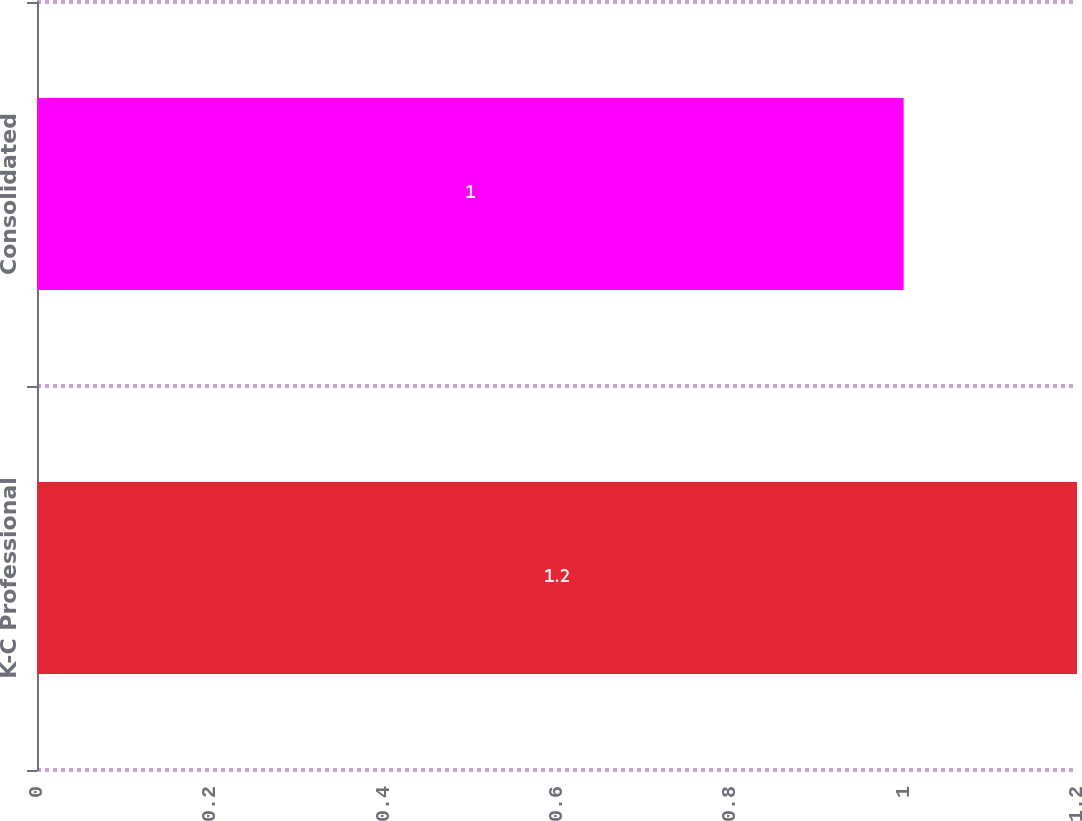Convert chart to OTSL. <chart><loc_0><loc_0><loc_500><loc_500><bar_chart><fcel>K-C Professional<fcel>Consolidated<nl><fcel>1.2<fcel>1<nl></chart> 